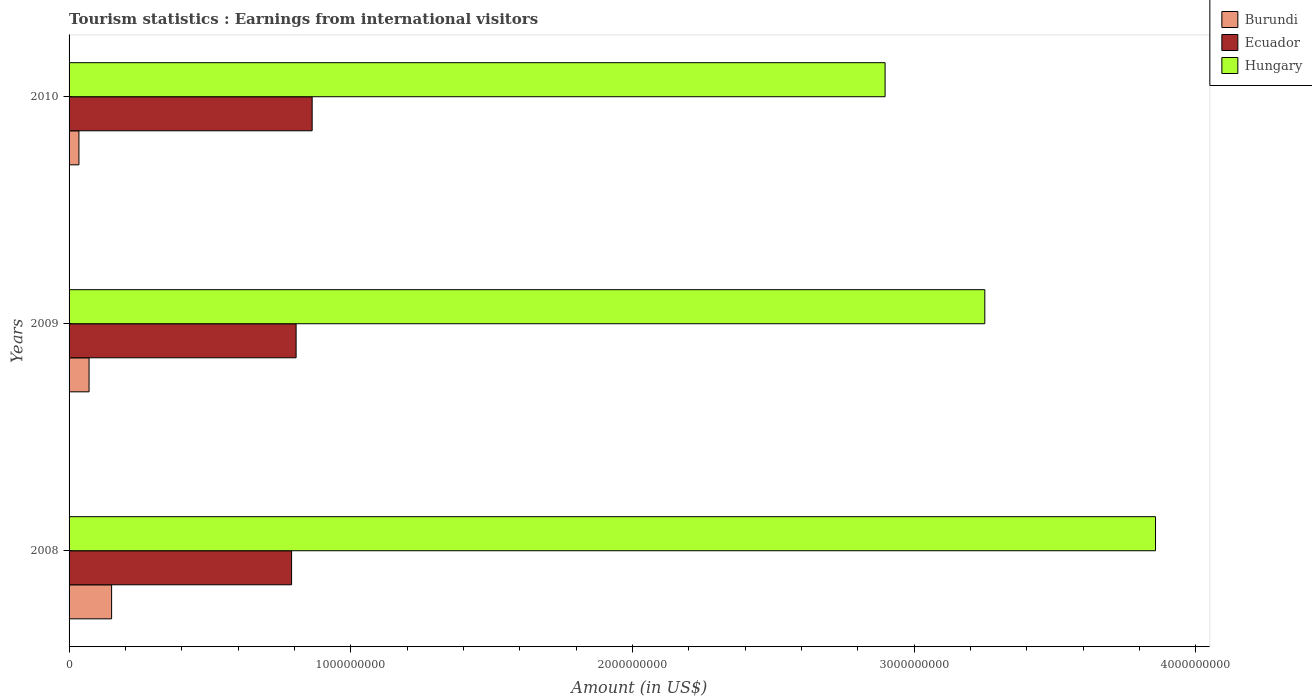How many different coloured bars are there?
Your answer should be very brief. 3. How many bars are there on the 1st tick from the top?
Offer a very short reply. 3. What is the label of the 2nd group of bars from the top?
Your answer should be compact. 2009. What is the earnings from international visitors in Hungary in 2009?
Your answer should be compact. 3.25e+09. Across all years, what is the maximum earnings from international visitors in Hungary?
Give a very brief answer. 3.86e+09. Across all years, what is the minimum earnings from international visitors in Ecuador?
Provide a short and direct response. 7.90e+08. What is the total earnings from international visitors in Burundi in the graph?
Provide a succinct answer. 2.57e+08. What is the difference between the earnings from international visitors in Ecuador in 2008 and that in 2010?
Provide a succinct answer. -7.30e+07. What is the difference between the earnings from international visitors in Ecuador in 2010 and the earnings from international visitors in Hungary in 2009?
Make the answer very short. -2.39e+09. What is the average earnings from international visitors in Burundi per year?
Keep it short and to the point. 8.57e+07. In the year 2010, what is the difference between the earnings from international visitors in Hungary and earnings from international visitors in Burundi?
Provide a short and direct response. 2.86e+09. In how many years, is the earnings from international visitors in Ecuador greater than 2400000000 US$?
Offer a terse response. 0. What is the ratio of the earnings from international visitors in Hungary in 2008 to that in 2009?
Your answer should be compact. 1.19. Is the earnings from international visitors in Hungary in 2009 less than that in 2010?
Make the answer very short. No. What is the difference between the highest and the second highest earnings from international visitors in Ecuador?
Keep it short and to the point. 5.70e+07. What is the difference between the highest and the lowest earnings from international visitors in Burundi?
Your response must be concise. 1.16e+08. In how many years, is the earnings from international visitors in Ecuador greater than the average earnings from international visitors in Ecuador taken over all years?
Give a very brief answer. 1. Is the sum of the earnings from international visitors in Hungary in 2009 and 2010 greater than the maximum earnings from international visitors in Ecuador across all years?
Provide a succinct answer. Yes. What does the 3rd bar from the top in 2009 represents?
Offer a very short reply. Burundi. What does the 1st bar from the bottom in 2009 represents?
Make the answer very short. Burundi. Is it the case that in every year, the sum of the earnings from international visitors in Ecuador and earnings from international visitors in Hungary is greater than the earnings from international visitors in Burundi?
Offer a terse response. Yes. How many bars are there?
Keep it short and to the point. 9. Are all the bars in the graph horizontal?
Offer a terse response. Yes. What is the difference between two consecutive major ticks on the X-axis?
Keep it short and to the point. 1.00e+09. What is the title of the graph?
Provide a succinct answer. Tourism statistics : Earnings from international visitors. Does "Norway" appear as one of the legend labels in the graph?
Keep it short and to the point. No. What is the label or title of the Y-axis?
Make the answer very short. Years. What is the Amount (in US$) of Burundi in 2008?
Your answer should be very brief. 1.51e+08. What is the Amount (in US$) of Ecuador in 2008?
Your answer should be very brief. 7.90e+08. What is the Amount (in US$) in Hungary in 2008?
Your answer should be very brief. 3.86e+09. What is the Amount (in US$) in Burundi in 2009?
Keep it short and to the point. 7.10e+07. What is the Amount (in US$) of Ecuador in 2009?
Your answer should be very brief. 8.06e+08. What is the Amount (in US$) of Hungary in 2009?
Your response must be concise. 3.25e+09. What is the Amount (in US$) of Burundi in 2010?
Offer a terse response. 3.50e+07. What is the Amount (in US$) in Ecuador in 2010?
Offer a terse response. 8.63e+08. What is the Amount (in US$) of Hungary in 2010?
Your answer should be compact. 2.90e+09. Across all years, what is the maximum Amount (in US$) of Burundi?
Your answer should be compact. 1.51e+08. Across all years, what is the maximum Amount (in US$) in Ecuador?
Offer a very short reply. 8.63e+08. Across all years, what is the maximum Amount (in US$) in Hungary?
Keep it short and to the point. 3.86e+09. Across all years, what is the minimum Amount (in US$) in Burundi?
Your answer should be compact. 3.50e+07. Across all years, what is the minimum Amount (in US$) in Ecuador?
Ensure brevity in your answer.  7.90e+08. Across all years, what is the minimum Amount (in US$) of Hungary?
Keep it short and to the point. 2.90e+09. What is the total Amount (in US$) of Burundi in the graph?
Make the answer very short. 2.57e+08. What is the total Amount (in US$) in Ecuador in the graph?
Offer a terse response. 2.46e+09. What is the total Amount (in US$) of Hungary in the graph?
Keep it short and to the point. 1.00e+1. What is the difference between the Amount (in US$) in Burundi in 2008 and that in 2009?
Offer a terse response. 8.00e+07. What is the difference between the Amount (in US$) of Ecuador in 2008 and that in 2009?
Your answer should be compact. -1.60e+07. What is the difference between the Amount (in US$) of Hungary in 2008 and that in 2009?
Keep it short and to the point. 6.06e+08. What is the difference between the Amount (in US$) of Burundi in 2008 and that in 2010?
Your answer should be compact. 1.16e+08. What is the difference between the Amount (in US$) in Ecuador in 2008 and that in 2010?
Provide a succinct answer. -7.30e+07. What is the difference between the Amount (in US$) of Hungary in 2008 and that in 2010?
Provide a short and direct response. 9.60e+08. What is the difference between the Amount (in US$) of Burundi in 2009 and that in 2010?
Make the answer very short. 3.60e+07. What is the difference between the Amount (in US$) in Ecuador in 2009 and that in 2010?
Your response must be concise. -5.70e+07. What is the difference between the Amount (in US$) in Hungary in 2009 and that in 2010?
Keep it short and to the point. 3.54e+08. What is the difference between the Amount (in US$) of Burundi in 2008 and the Amount (in US$) of Ecuador in 2009?
Your response must be concise. -6.55e+08. What is the difference between the Amount (in US$) in Burundi in 2008 and the Amount (in US$) in Hungary in 2009?
Your answer should be very brief. -3.10e+09. What is the difference between the Amount (in US$) of Ecuador in 2008 and the Amount (in US$) of Hungary in 2009?
Provide a succinct answer. -2.46e+09. What is the difference between the Amount (in US$) in Burundi in 2008 and the Amount (in US$) in Ecuador in 2010?
Ensure brevity in your answer.  -7.12e+08. What is the difference between the Amount (in US$) in Burundi in 2008 and the Amount (in US$) in Hungary in 2010?
Your answer should be compact. -2.75e+09. What is the difference between the Amount (in US$) of Ecuador in 2008 and the Amount (in US$) of Hungary in 2010?
Offer a terse response. -2.11e+09. What is the difference between the Amount (in US$) of Burundi in 2009 and the Amount (in US$) of Ecuador in 2010?
Provide a short and direct response. -7.92e+08. What is the difference between the Amount (in US$) in Burundi in 2009 and the Amount (in US$) in Hungary in 2010?
Your response must be concise. -2.83e+09. What is the difference between the Amount (in US$) of Ecuador in 2009 and the Amount (in US$) of Hungary in 2010?
Offer a very short reply. -2.09e+09. What is the average Amount (in US$) of Burundi per year?
Give a very brief answer. 8.57e+07. What is the average Amount (in US$) of Ecuador per year?
Offer a very short reply. 8.20e+08. What is the average Amount (in US$) in Hungary per year?
Ensure brevity in your answer.  3.34e+09. In the year 2008, what is the difference between the Amount (in US$) in Burundi and Amount (in US$) in Ecuador?
Make the answer very short. -6.39e+08. In the year 2008, what is the difference between the Amount (in US$) of Burundi and Amount (in US$) of Hungary?
Make the answer very short. -3.71e+09. In the year 2008, what is the difference between the Amount (in US$) in Ecuador and Amount (in US$) in Hungary?
Keep it short and to the point. -3.07e+09. In the year 2009, what is the difference between the Amount (in US$) of Burundi and Amount (in US$) of Ecuador?
Provide a short and direct response. -7.35e+08. In the year 2009, what is the difference between the Amount (in US$) in Burundi and Amount (in US$) in Hungary?
Provide a short and direct response. -3.18e+09. In the year 2009, what is the difference between the Amount (in US$) in Ecuador and Amount (in US$) in Hungary?
Keep it short and to the point. -2.44e+09. In the year 2010, what is the difference between the Amount (in US$) of Burundi and Amount (in US$) of Ecuador?
Your answer should be very brief. -8.28e+08. In the year 2010, what is the difference between the Amount (in US$) of Burundi and Amount (in US$) of Hungary?
Offer a very short reply. -2.86e+09. In the year 2010, what is the difference between the Amount (in US$) in Ecuador and Amount (in US$) in Hungary?
Provide a short and direct response. -2.03e+09. What is the ratio of the Amount (in US$) in Burundi in 2008 to that in 2009?
Offer a terse response. 2.13. What is the ratio of the Amount (in US$) in Ecuador in 2008 to that in 2009?
Provide a short and direct response. 0.98. What is the ratio of the Amount (in US$) in Hungary in 2008 to that in 2009?
Give a very brief answer. 1.19. What is the ratio of the Amount (in US$) in Burundi in 2008 to that in 2010?
Offer a very short reply. 4.31. What is the ratio of the Amount (in US$) of Ecuador in 2008 to that in 2010?
Provide a short and direct response. 0.92. What is the ratio of the Amount (in US$) in Hungary in 2008 to that in 2010?
Your response must be concise. 1.33. What is the ratio of the Amount (in US$) of Burundi in 2009 to that in 2010?
Give a very brief answer. 2.03. What is the ratio of the Amount (in US$) in Ecuador in 2009 to that in 2010?
Your response must be concise. 0.93. What is the ratio of the Amount (in US$) of Hungary in 2009 to that in 2010?
Make the answer very short. 1.12. What is the difference between the highest and the second highest Amount (in US$) in Burundi?
Ensure brevity in your answer.  8.00e+07. What is the difference between the highest and the second highest Amount (in US$) of Ecuador?
Your answer should be very brief. 5.70e+07. What is the difference between the highest and the second highest Amount (in US$) of Hungary?
Offer a terse response. 6.06e+08. What is the difference between the highest and the lowest Amount (in US$) in Burundi?
Offer a terse response. 1.16e+08. What is the difference between the highest and the lowest Amount (in US$) in Ecuador?
Keep it short and to the point. 7.30e+07. What is the difference between the highest and the lowest Amount (in US$) of Hungary?
Keep it short and to the point. 9.60e+08. 